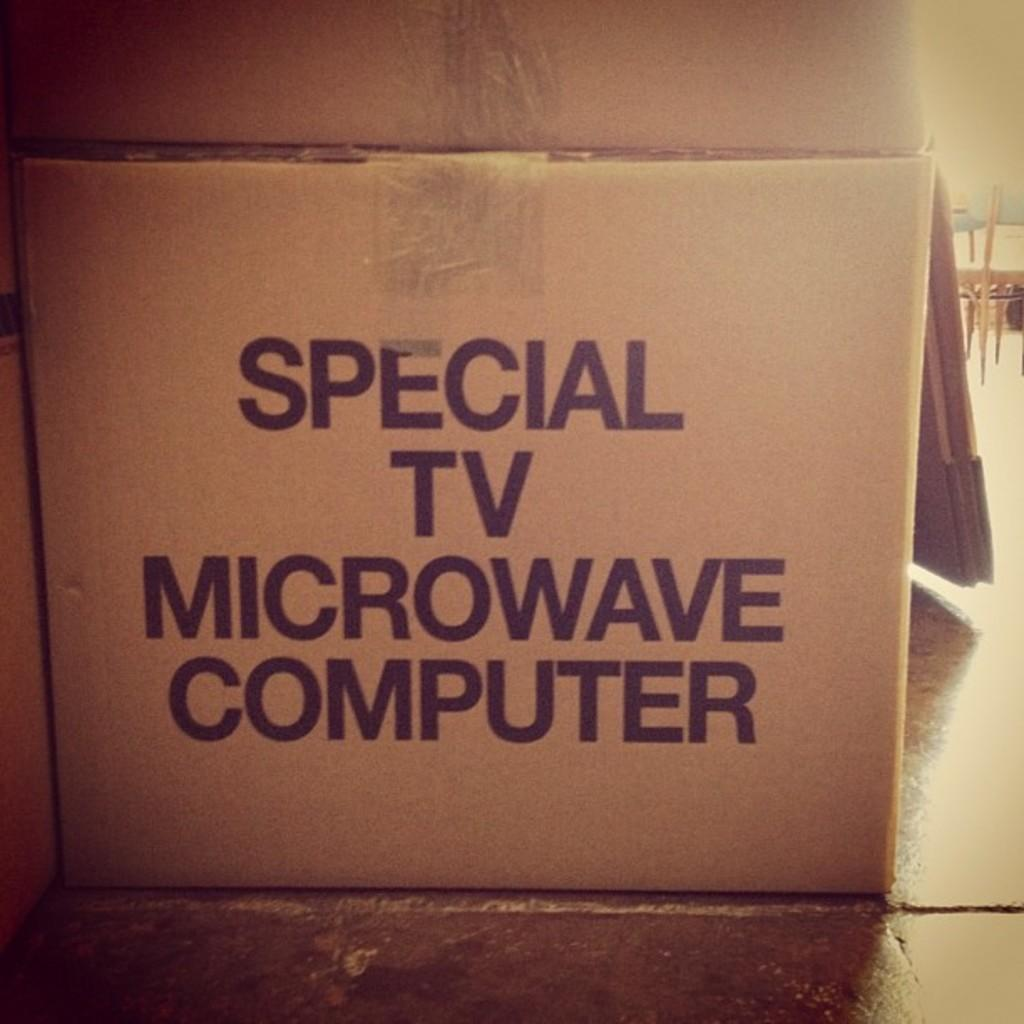<image>
Summarize the visual content of the image. a cardboard box labeled for special TV microwave computer on the floor 